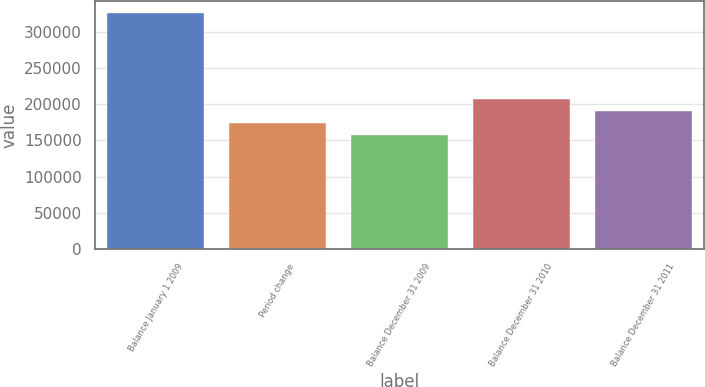Convert chart. <chart><loc_0><loc_0><loc_500><loc_500><bar_chart><fcel>Balance January 1 2009<fcel>Period change<fcel>Balance December 31 2009<fcel>Balance December 31 2010<fcel>Balance December 31 2011<nl><fcel>326693<fcel>173956<fcel>156985<fcel>207897<fcel>190927<nl></chart> 